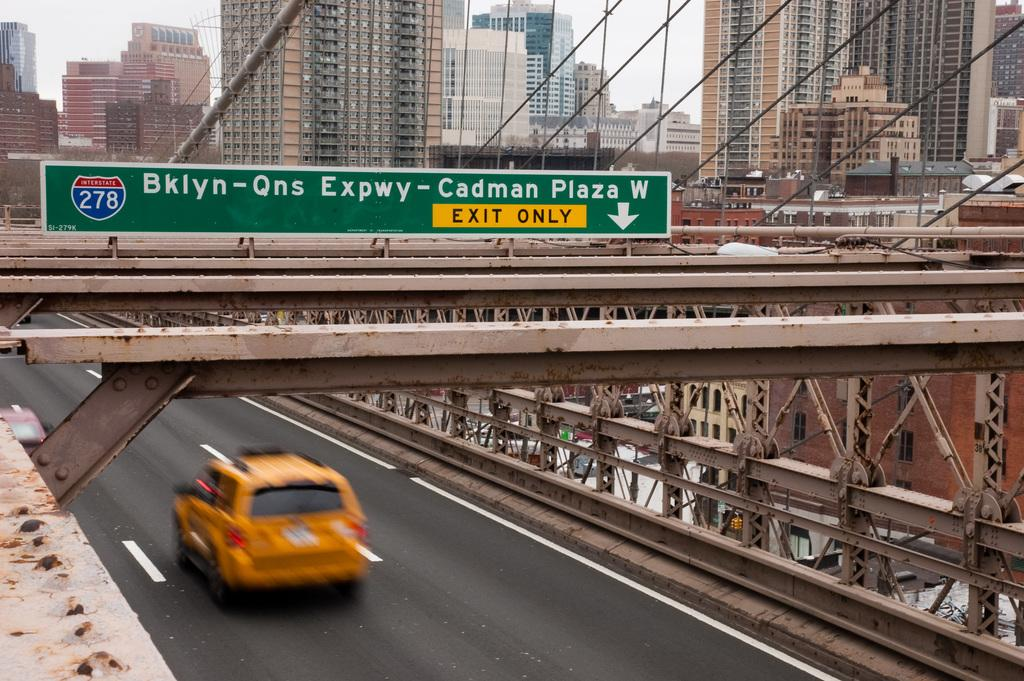<image>
Offer a succinct explanation of the picture presented. An Orange SUV is driving down a highway under an overpass that has a sign which says Exit Only. 